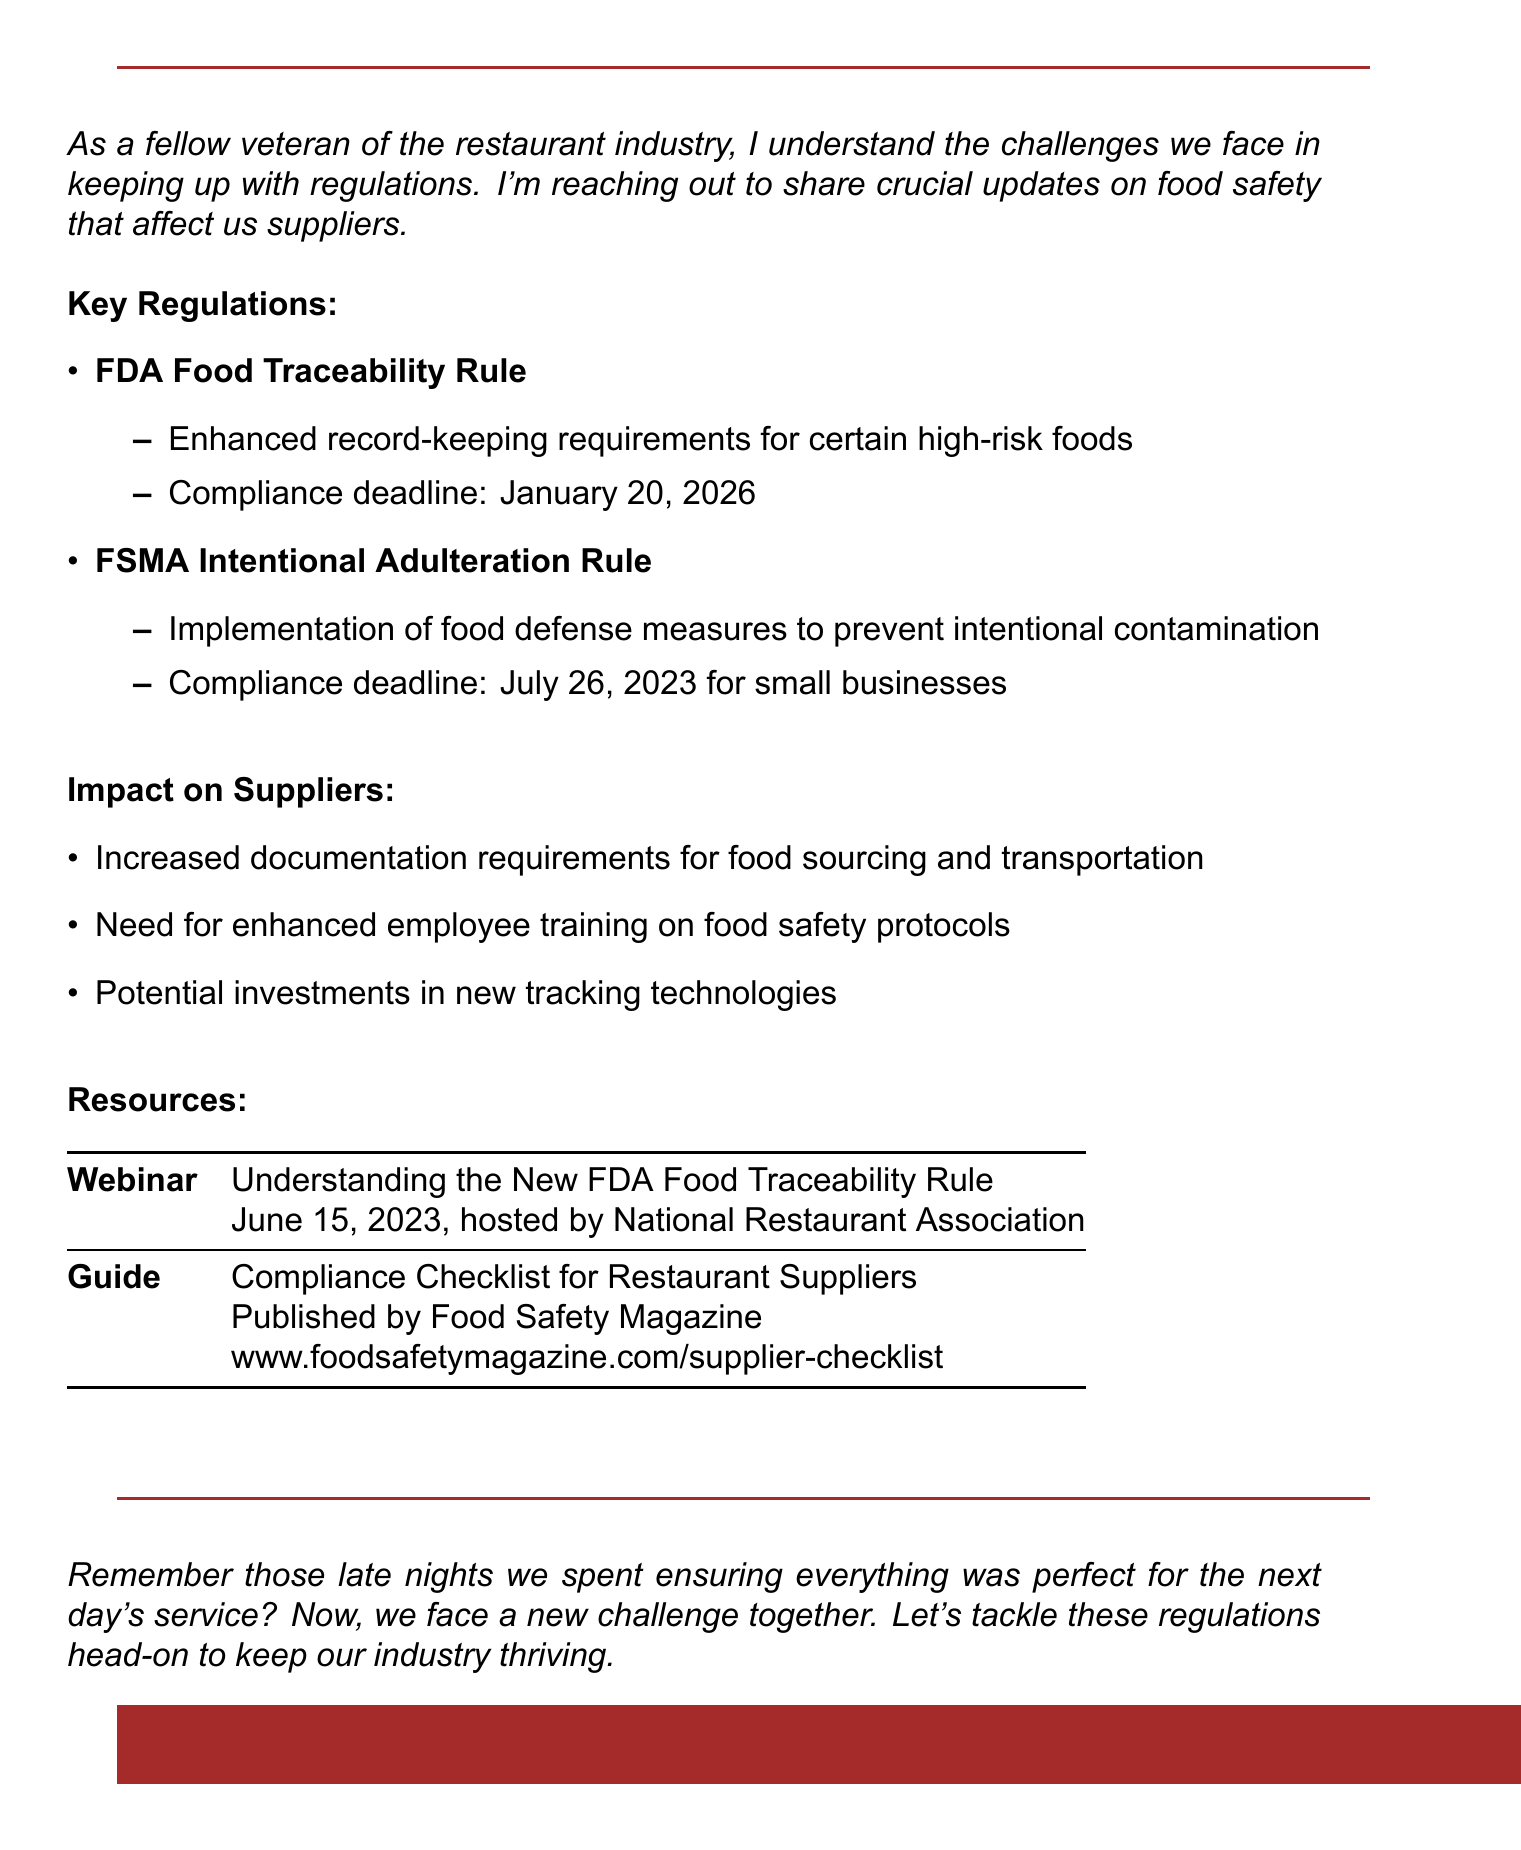What is the subject of the email? The subject is the title of the email which summarizes its main topic.
Answer: Important Update: New Food Safety Regulations for Restaurant Suppliers What is the compliance deadline for the FDA Food Traceability Rule? This is the date by which suppliers must comply with the specified regulation.
Answer: January 20, 2026 What does the FSMA Intentional Adulteration Rule focus on? This provides insight into the specific requirement of the regulation mentioned.
Answer: Food defense measures to prevent intentional contamination Which organization hosted the webinar on food traceability? This is the name of the organization responsible for providing the webinar.
Answer: National Restaurant Association What is one impact on suppliers mentioned in the document? This indicates a specific effect the regulations will have on suppliers.
Answer: Increased documentation requirements for food sourcing and transportation What type of document is this? This identifies the general format and purpose of the content.
Answer: Email What is the publication source for the compliance checklist? This reveals where the checklist for suppliers can be referred to.
Answer: Food Safety Magazine What training is required for employees due to the new regulations? This specifies the focus area for employee training as part of compliance.
Answer: Enhanced employee training on food safety protocols 